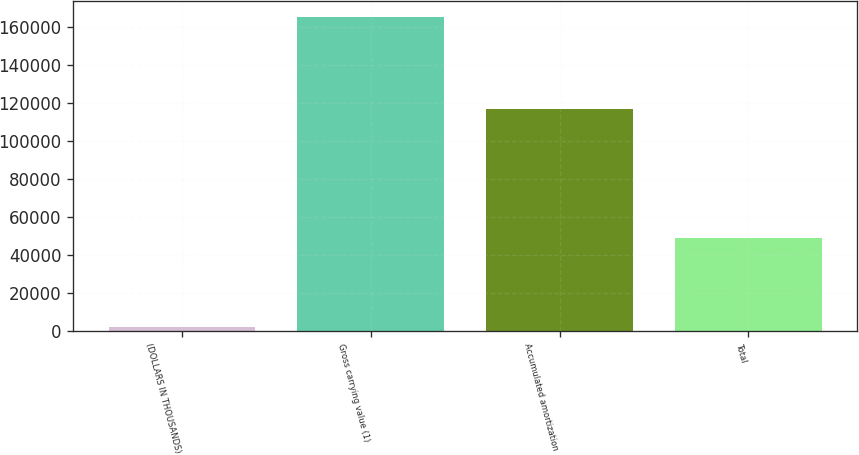Convert chart to OTSL. <chart><loc_0><loc_0><loc_500><loc_500><bar_chart><fcel>(DOLLARS IN THOUSANDS)<fcel>Gross carrying value (1)<fcel>Accumulated amortization<fcel>Total<nl><fcel>2010<fcel>165406<fcel>116572<fcel>48834<nl></chart> 